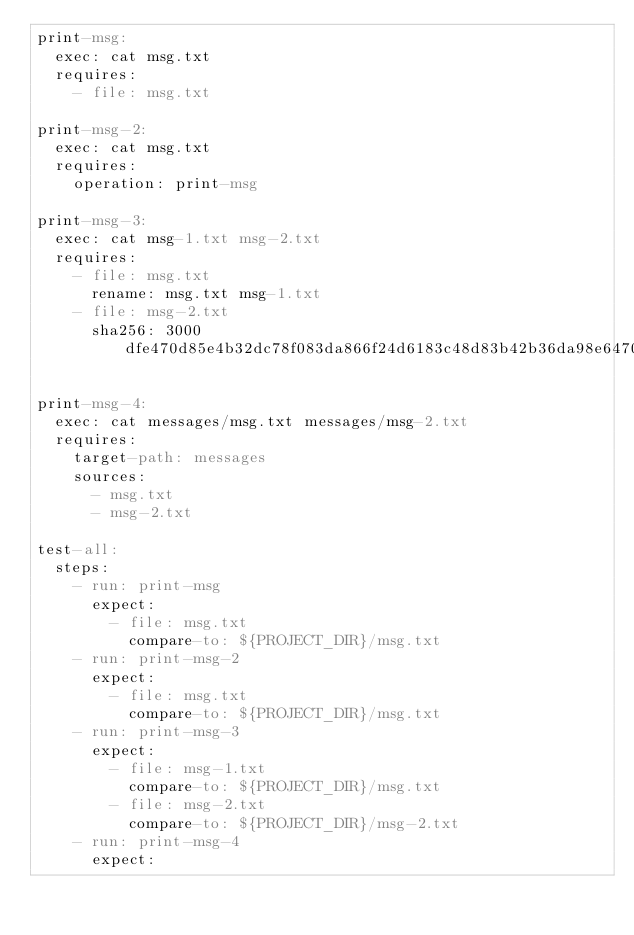Convert code to text. <code><loc_0><loc_0><loc_500><loc_500><_YAML_>print-msg:
  exec: cat msg.txt
  requires:
    - file: msg.txt

print-msg-2:
  exec: cat msg.txt
  requires:
    operation: print-msg

print-msg-3:
  exec: cat msg-1.txt msg-2.txt
  requires:
    - file: msg.txt
      rename: msg.txt msg-1.txt
    - file: msg-2.txt
      sha256: 3000dfe470d85e4b32dc78f083da866f24d6183c48d83b42b36da98e64701ade

print-msg-4:
  exec: cat messages/msg.txt messages/msg-2.txt
  requires:
    target-path: messages
    sources:
      - msg.txt
      - msg-2.txt

test-all:
  steps:
    - run: print-msg
      expect:
        - file: msg.txt
          compare-to: ${PROJECT_DIR}/msg.txt
    - run: print-msg-2
      expect:
        - file: msg.txt
          compare-to: ${PROJECT_DIR}/msg.txt
    - run: print-msg-3
      expect:
        - file: msg-1.txt
          compare-to: ${PROJECT_DIR}/msg.txt
        - file: msg-2.txt
          compare-to: ${PROJECT_DIR}/msg-2.txt
    - run: print-msg-4
      expect:</code> 